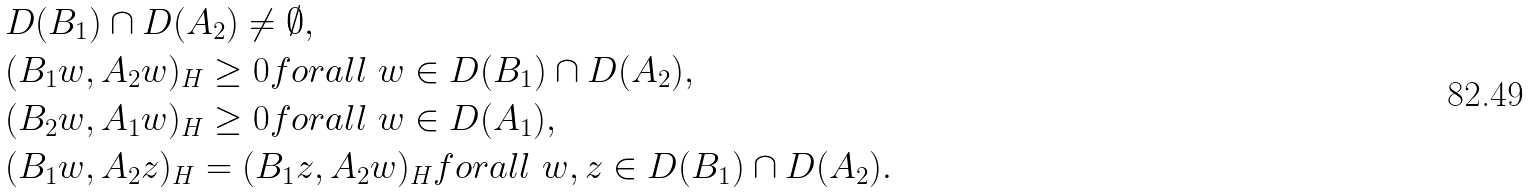Convert formula to latex. <formula><loc_0><loc_0><loc_500><loc_500>& D ( B _ { 1 } ) \cap D ( A _ { 2 } ) \neq \emptyset , \\ & ( B _ { 1 } w , A _ { 2 } w ) _ { H } \geq 0 f o r a l l \ w \in D ( B _ { 1 } ) \cap D ( A _ { 2 } ) , \\ & ( B _ { 2 } w , A _ { 1 } w ) _ { H } \geq 0 f o r a l l \ w \in D ( A _ { 1 } ) , \\ & ( B _ { 1 } w , A _ { 2 } z ) _ { H } = ( B _ { 1 } z , A _ { 2 } w ) _ { H } f o r a l l \ w , z \in D ( B _ { 1 } ) \cap D ( A _ { 2 } ) .</formula> 